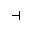<formula> <loc_0><loc_0><loc_500><loc_500>\dashv</formula> 